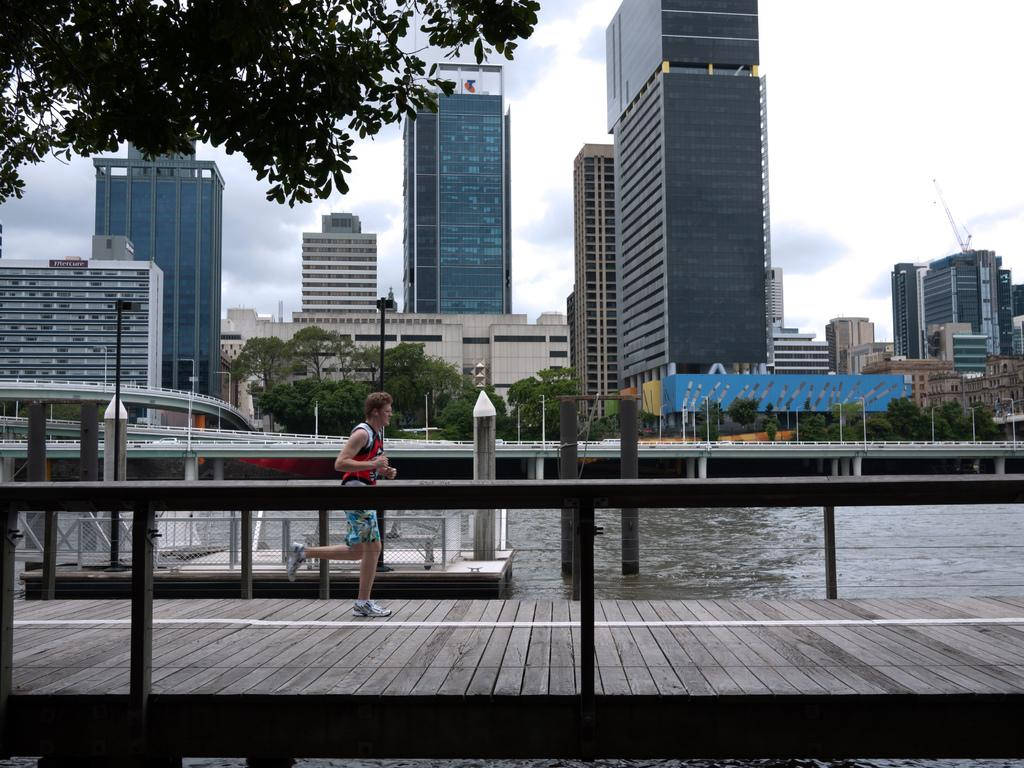What is the man in the image doing? The man is running in the image. What surface is the man running on? The man is running on a wooden path. What can be seen in the background of the image? There is a bridge, buildings, a tree, and the sky visible in the background of the image. Can you tell me how many ducks are swimming in the water near the bridge? There is no water or ducks present in the image; it features a man running on a wooden path with a bridge, buildings, a tree, and the sky in the background. 